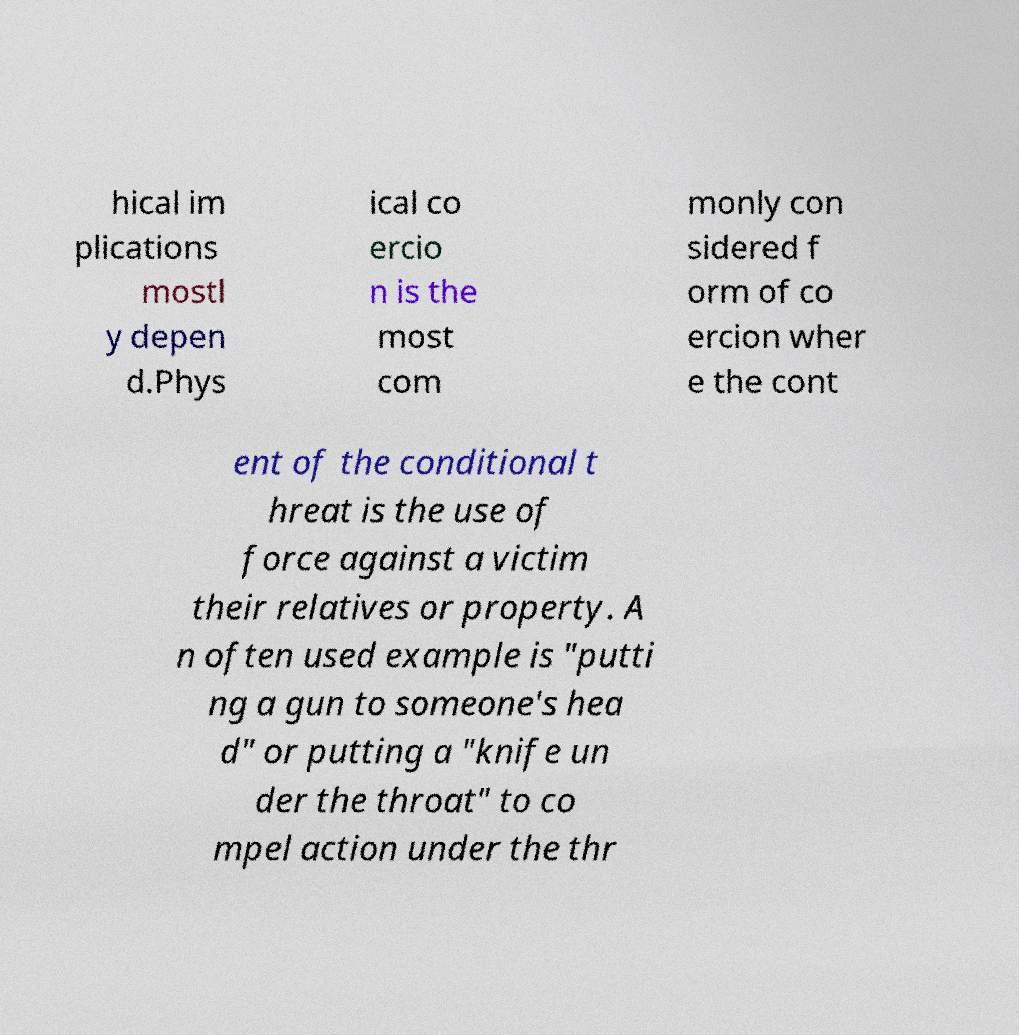Please read and relay the text visible in this image. What does it say? hical im plications mostl y depen d.Phys ical co ercio n is the most com monly con sidered f orm of co ercion wher e the cont ent of the conditional t hreat is the use of force against a victim their relatives or property. A n often used example is "putti ng a gun to someone's hea d" or putting a "knife un der the throat" to co mpel action under the thr 